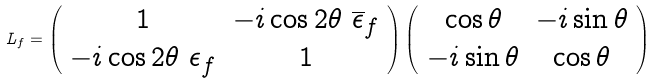Convert formula to latex. <formula><loc_0><loc_0><loc_500><loc_500>L _ { f } = \left ( \begin{array} { c c } 1 & - i \cos 2 \theta \ \overline { \epsilon } _ { f } \\ - i \cos 2 \theta \ \epsilon _ { f } & 1 \end{array} \right ) \left ( \begin{array} { c c } \cos \theta & - i \sin \theta \\ - i \sin \theta & \cos \theta \end{array} \right )</formula> 